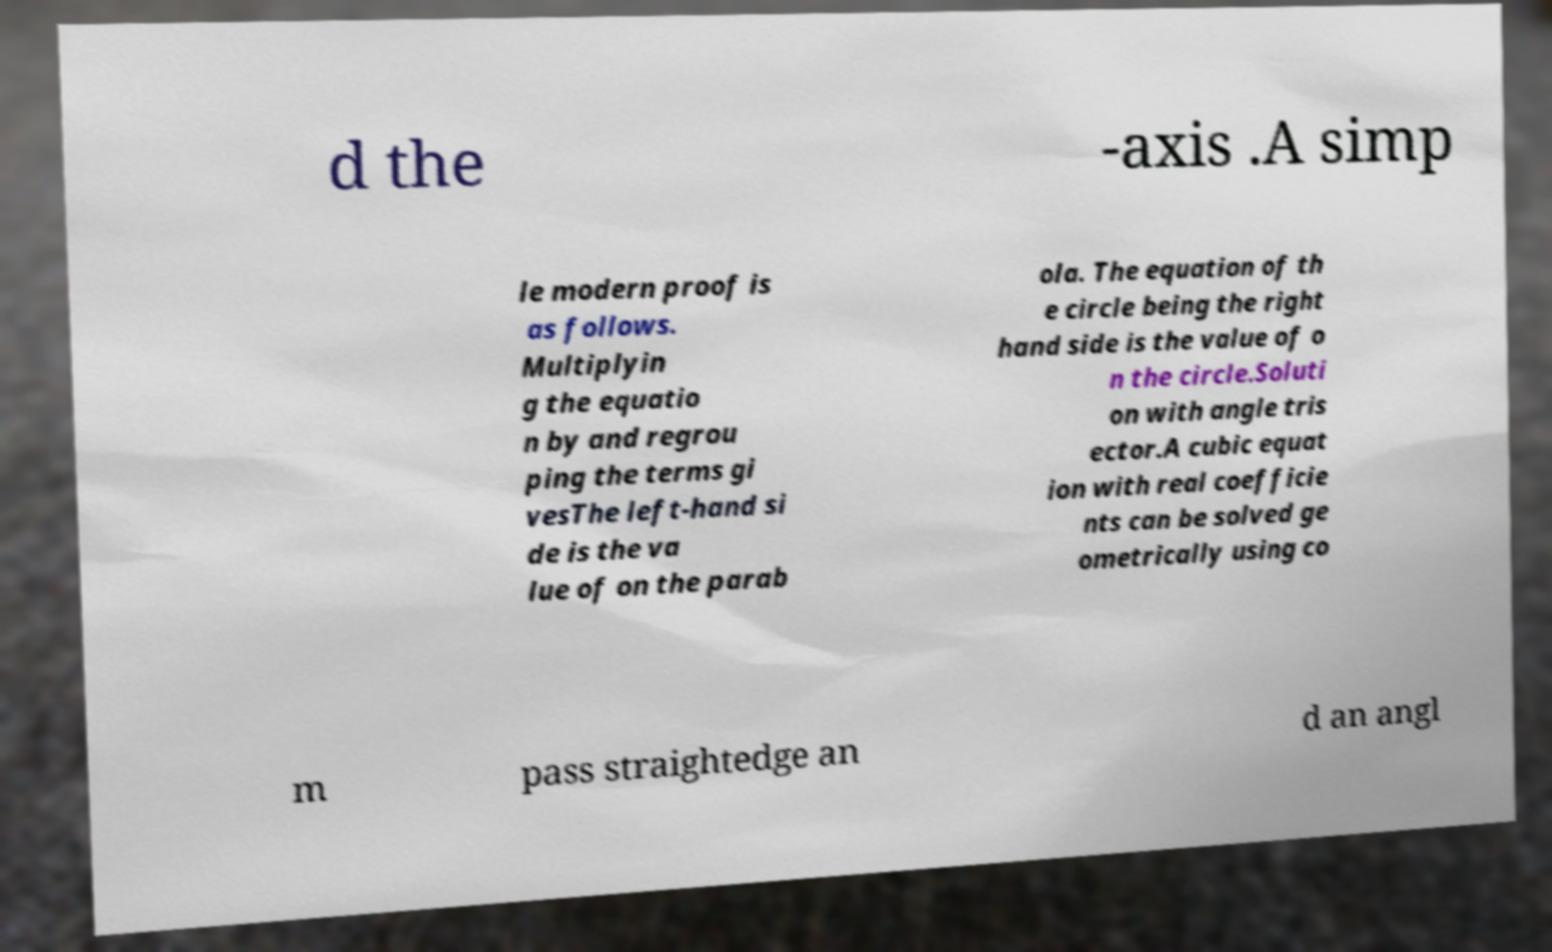Could you extract and type out the text from this image? d the -axis .A simp le modern proof is as follows. Multiplyin g the equatio n by and regrou ping the terms gi vesThe left-hand si de is the va lue of on the parab ola. The equation of th e circle being the right hand side is the value of o n the circle.Soluti on with angle tris ector.A cubic equat ion with real coefficie nts can be solved ge ometrically using co m pass straightedge an d an angl 